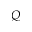<formula> <loc_0><loc_0><loc_500><loc_500>Q</formula> 